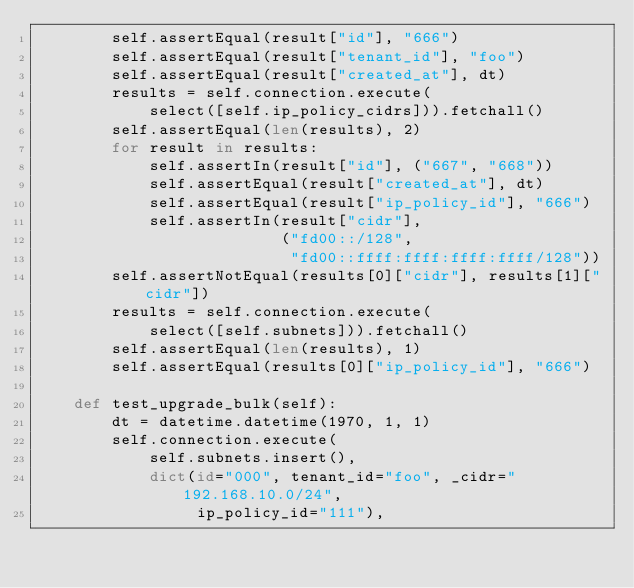Convert code to text. <code><loc_0><loc_0><loc_500><loc_500><_Python_>        self.assertEqual(result["id"], "666")
        self.assertEqual(result["tenant_id"], "foo")
        self.assertEqual(result["created_at"], dt)
        results = self.connection.execute(
            select([self.ip_policy_cidrs])).fetchall()
        self.assertEqual(len(results), 2)
        for result in results:
            self.assertIn(result["id"], ("667", "668"))
            self.assertEqual(result["created_at"], dt)
            self.assertEqual(result["ip_policy_id"], "666")
            self.assertIn(result["cidr"],
                          ("fd00::/128",
                           "fd00::ffff:ffff:ffff:ffff/128"))
        self.assertNotEqual(results[0]["cidr"], results[1]["cidr"])
        results = self.connection.execute(
            select([self.subnets])).fetchall()
        self.assertEqual(len(results), 1)
        self.assertEqual(results[0]["ip_policy_id"], "666")

    def test_upgrade_bulk(self):
        dt = datetime.datetime(1970, 1, 1)
        self.connection.execute(
            self.subnets.insert(),
            dict(id="000", tenant_id="foo", _cidr="192.168.10.0/24",
                 ip_policy_id="111"),</code> 